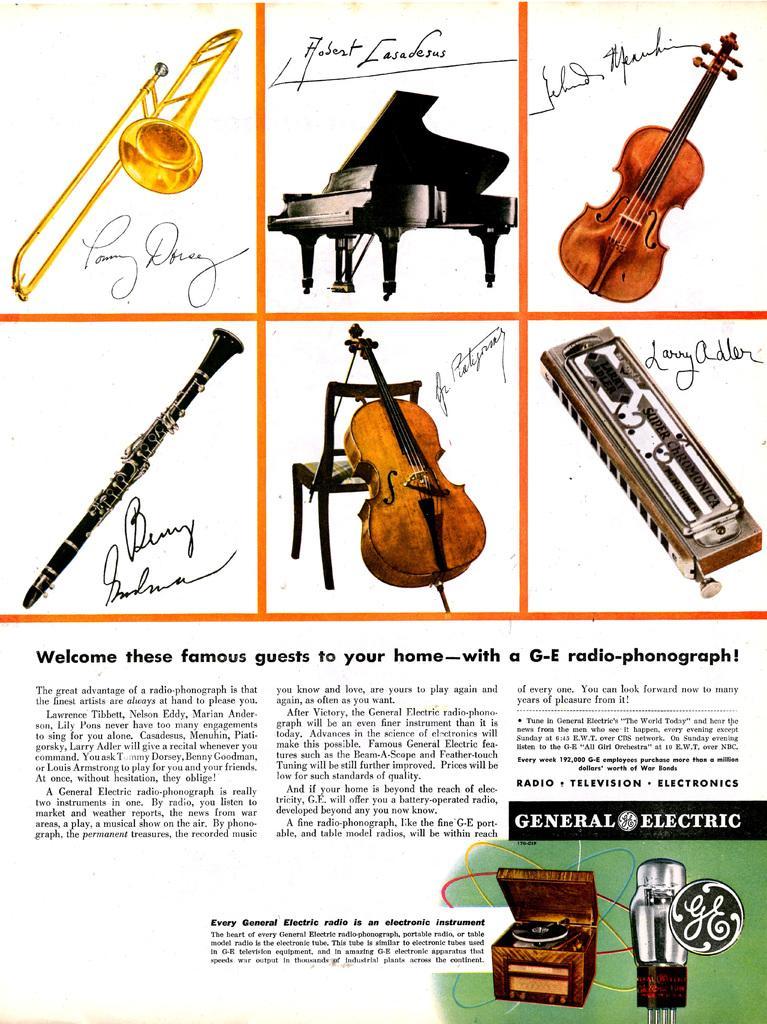How would you summarize this image in a sentence or two? This picture consists of a poster, in which there are different musical instruments in the image. 